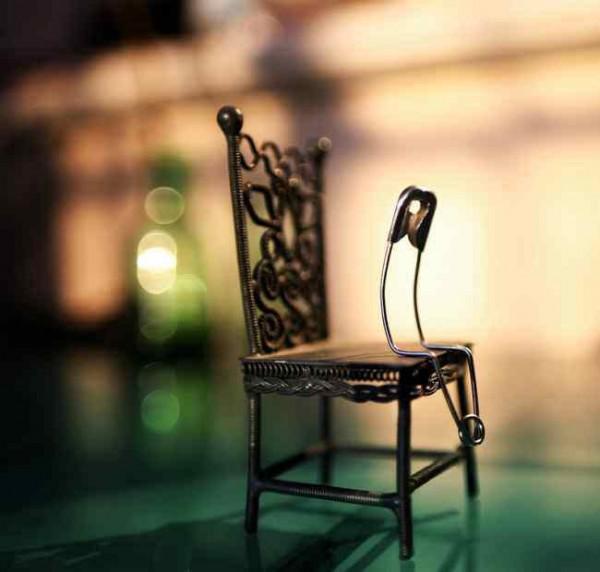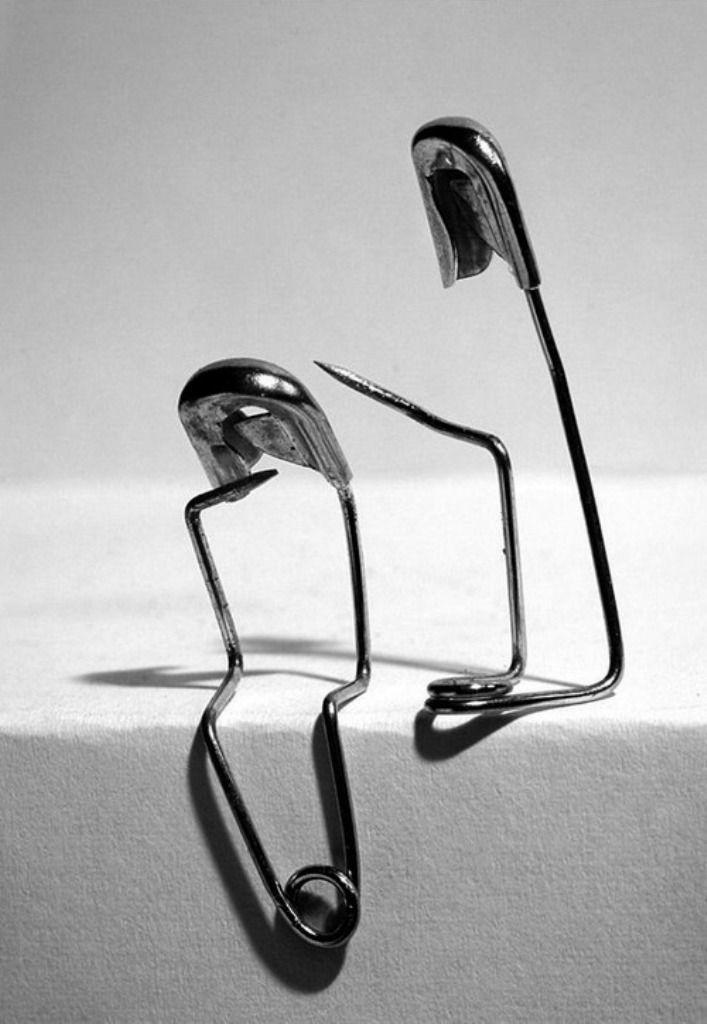The first image is the image on the left, the second image is the image on the right. Assess this claim about the two images: "One safety pin is open and bent with it' sharp point above another safety pin.". Correct or not? Answer yes or no. Yes. The first image is the image on the left, the second image is the image on the right. For the images shown, is this caption "a bobby pin is bent and sitting on a tiny chair" true? Answer yes or no. Yes. 